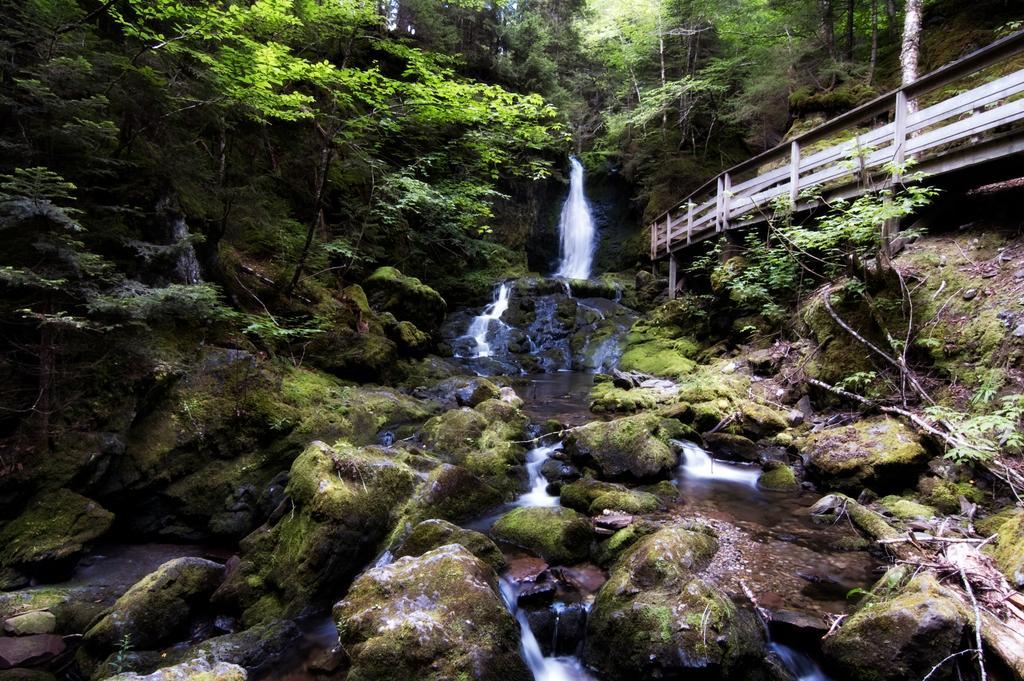Can you describe this image briefly? In the image there are rocks with algae. In the background there is waterfall and also there are many trees. On the right side of the image there is railing. 